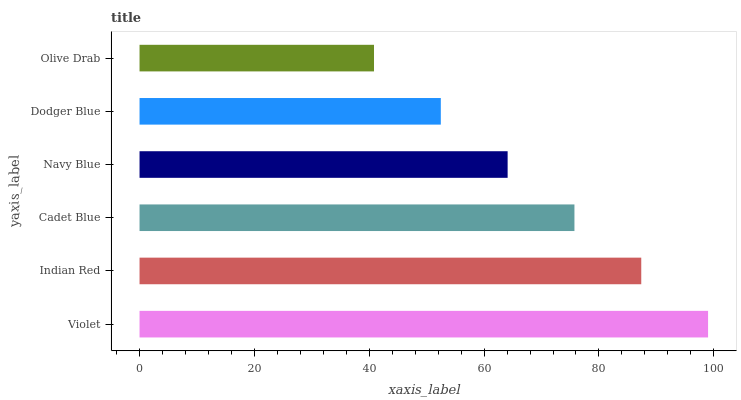Is Olive Drab the minimum?
Answer yes or no. Yes. Is Violet the maximum?
Answer yes or no. Yes. Is Indian Red the minimum?
Answer yes or no. No. Is Indian Red the maximum?
Answer yes or no. No. Is Violet greater than Indian Red?
Answer yes or no. Yes. Is Indian Red less than Violet?
Answer yes or no. Yes. Is Indian Red greater than Violet?
Answer yes or no. No. Is Violet less than Indian Red?
Answer yes or no. No. Is Cadet Blue the high median?
Answer yes or no. Yes. Is Navy Blue the low median?
Answer yes or no. Yes. Is Navy Blue the high median?
Answer yes or no. No. Is Indian Red the low median?
Answer yes or no. No. 